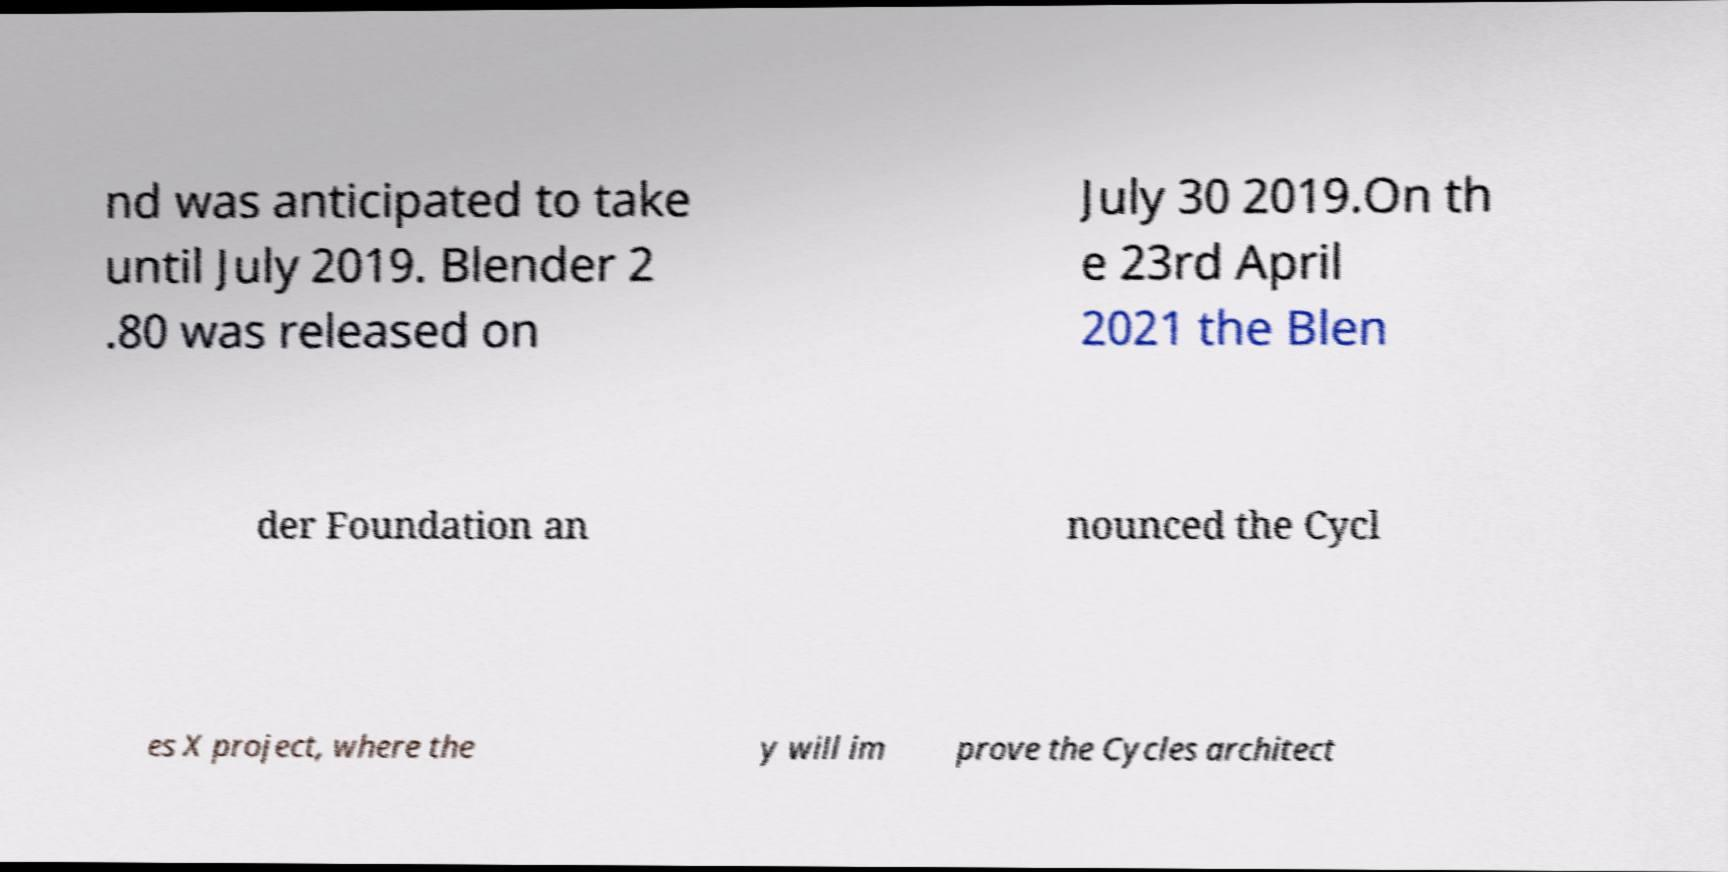I need the written content from this picture converted into text. Can you do that? nd was anticipated to take until July 2019. Blender 2 .80 was released on July 30 2019.On th e 23rd April 2021 the Blen der Foundation an nounced the Cycl es X project, where the y will im prove the Cycles architect 